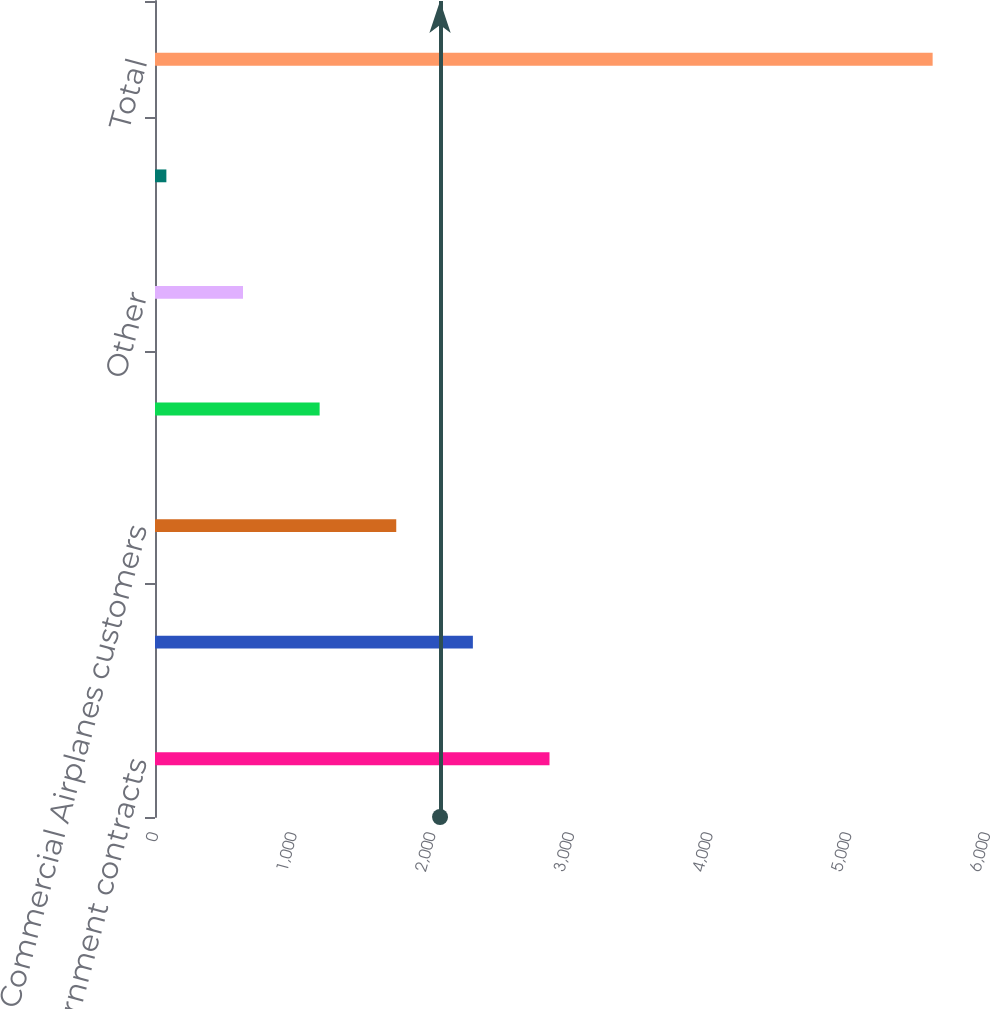Convert chart to OTSL. <chart><loc_0><loc_0><loc_500><loc_500><bar_chart><fcel>US government contracts<fcel>Defense Space & Security<fcel>Commercial Airplanes customers<fcel>Reinsurance receivables<fcel>Other<fcel>Less valuation allowance<fcel>Total<nl><fcel>2845<fcel>2292.4<fcel>1739.8<fcel>1187.2<fcel>634.6<fcel>82<fcel>5608<nl></chart> 